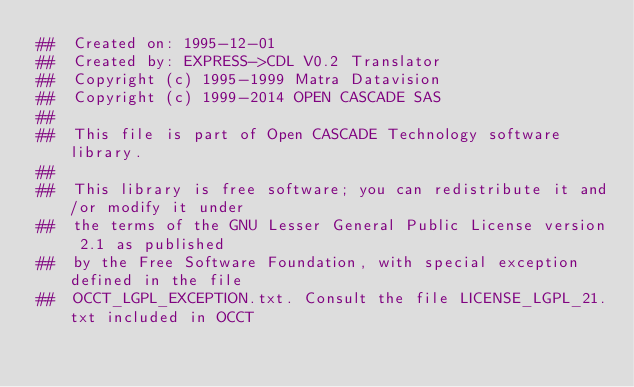Convert code to text. <code><loc_0><loc_0><loc_500><loc_500><_Nim_>##  Created on: 1995-12-01
##  Created by: EXPRESS->CDL V0.2 Translator
##  Copyright (c) 1995-1999 Matra Datavision
##  Copyright (c) 1999-2014 OPEN CASCADE SAS
##
##  This file is part of Open CASCADE Technology software library.
##
##  This library is free software; you can redistribute it and/or modify it under
##  the terms of the GNU Lesser General Public License version 2.1 as published
##  by the Free Software Foundation, with special exception defined in the file
##  OCCT_LGPL_EXCEPTION.txt. Consult the file LICENSE_LGPL_21.txt included in OCCT</code> 